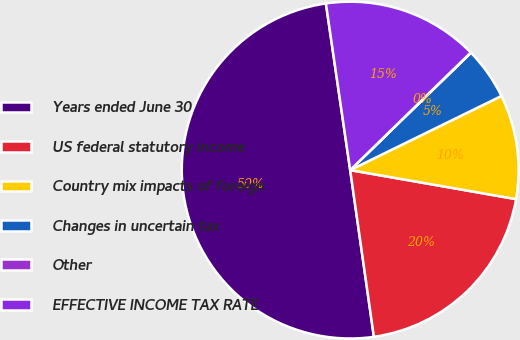<chart> <loc_0><loc_0><loc_500><loc_500><pie_chart><fcel>Years ended June 30<fcel>US federal statutory income<fcel>Country mix impacts of foreign<fcel>Changes in uncertain tax<fcel>Other<fcel>EFFECTIVE INCOME TAX RATE<nl><fcel>49.94%<fcel>19.99%<fcel>10.01%<fcel>5.02%<fcel>0.03%<fcel>15.0%<nl></chart> 